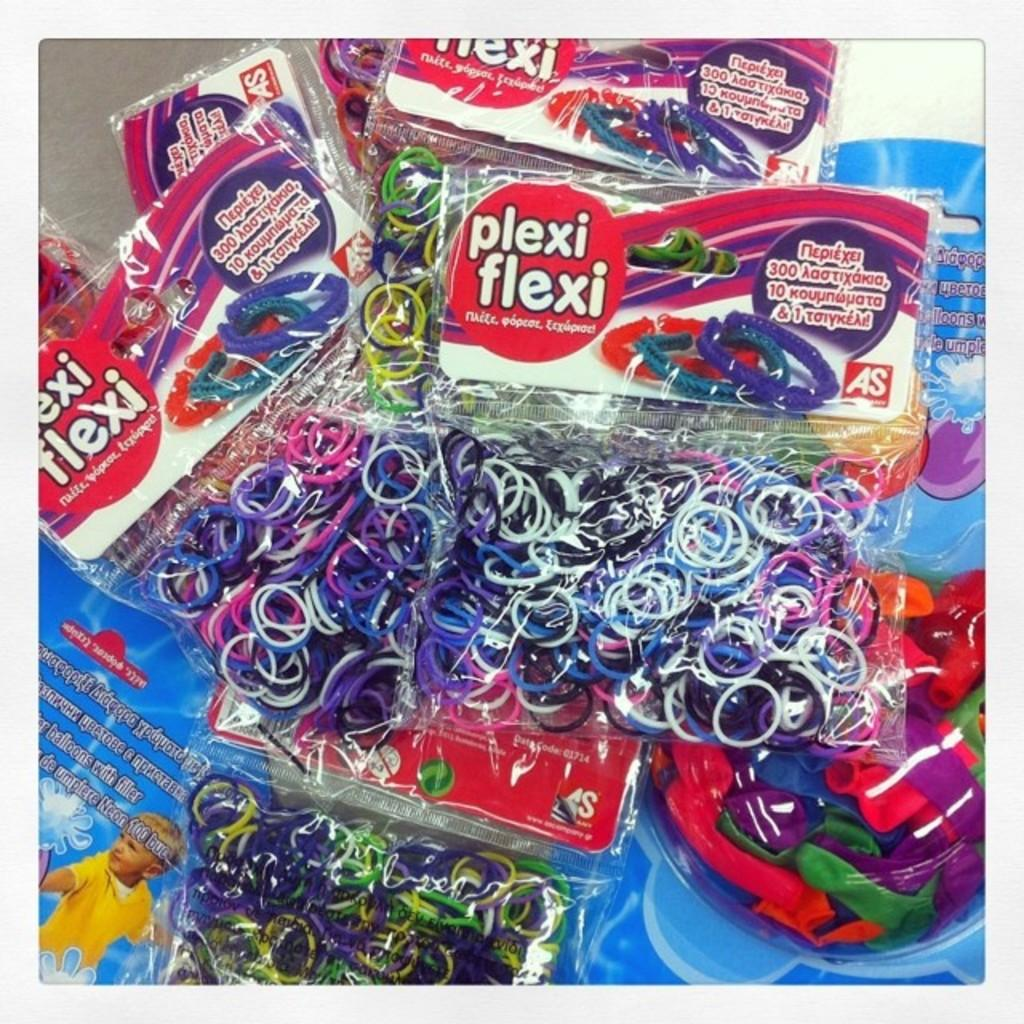What objects are present in the image that are typically used for decoration or celebration? There are balloons in the image. How are the balloons packaged? The balloons are in packets. What else can be found in the packets besides balloons? There are bands in the packets. What other items are visible in the image? There are posters in the image. Where are the packets and posters located? The packets and posters are placed on a platform. What type of underwear is being used as a decoration in the image? There is no underwear present in the image; it features balloons, packets, bands, and posters. 